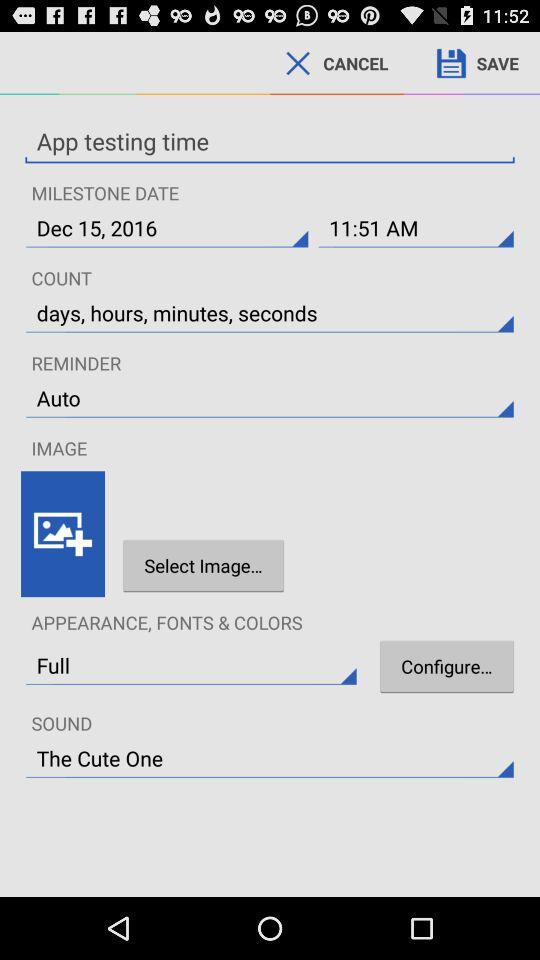What is the given date of the milestone? The given date of the milestone is December 15, 2016. 